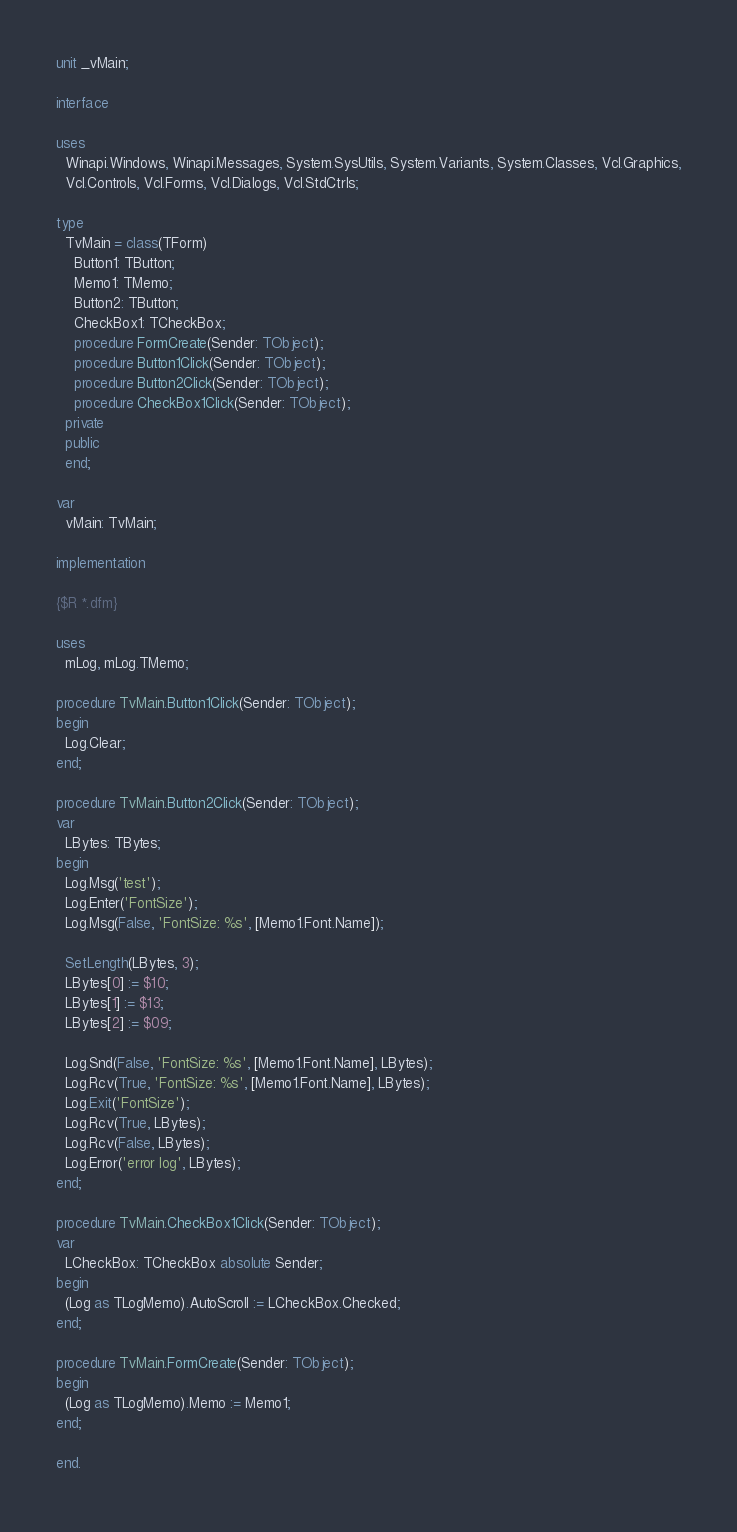Convert code to text. <code><loc_0><loc_0><loc_500><loc_500><_Pascal_>unit _vMain;

interface

uses
  Winapi.Windows, Winapi.Messages, System.SysUtils, System.Variants, System.Classes, Vcl.Graphics,
  Vcl.Controls, Vcl.Forms, Vcl.Dialogs, Vcl.StdCtrls;

type
  TvMain = class(TForm)
    Button1: TButton;
    Memo1: TMemo;
    Button2: TButton;
    CheckBox1: TCheckBox;
    procedure FormCreate(Sender: TObject);
    procedure Button1Click(Sender: TObject);
    procedure Button2Click(Sender: TObject);
    procedure CheckBox1Click(Sender: TObject);
  private
  public
  end;

var
  vMain: TvMain;

implementation

{$R *.dfm}

uses
  mLog, mLog.TMemo;

procedure TvMain.Button1Click(Sender: TObject);
begin
  Log.Clear;
end;

procedure TvMain.Button2Click(Sender: TObject);
var
  LBytes: TBytes;
begin
  Log.Msg('test');
  Log.Enter('FontSize');
  Log.Msg(False, 'FontSize: %s', [Memo1.Font.Name]);

  SetLength(LBytes, 3);
  LBytes[0] := $10;
  LBytes[1] := $13;
  LBytes[2] := $09;

  Log.Snd(False, 'FontSize: %s', [Memo1.Font.Name], LBytes);
  Log.Rcv(True, 'FontSize: %s', [Memo1.Font.Name], LBytes);
  Log.Exit('FontSize');
  Log.Rcv(True, LBytes);
  Log.Rcv(False, LBytes);
  Log.Error('error log', LBytes);
end;

procedure TvMain.CheckBox1Click(Sender: TObject);
var
  LCheckBox: TCheckBox absolute Sender;
begin
  (Log as TLogMemo).AutoScroll := LCheckBox.Checked;
end;

procedure TvMain.FormCreate(Sender: TObject);
begin
  (Log as TLogMemo).Memo := Memo1;
end;

end.
</code> 